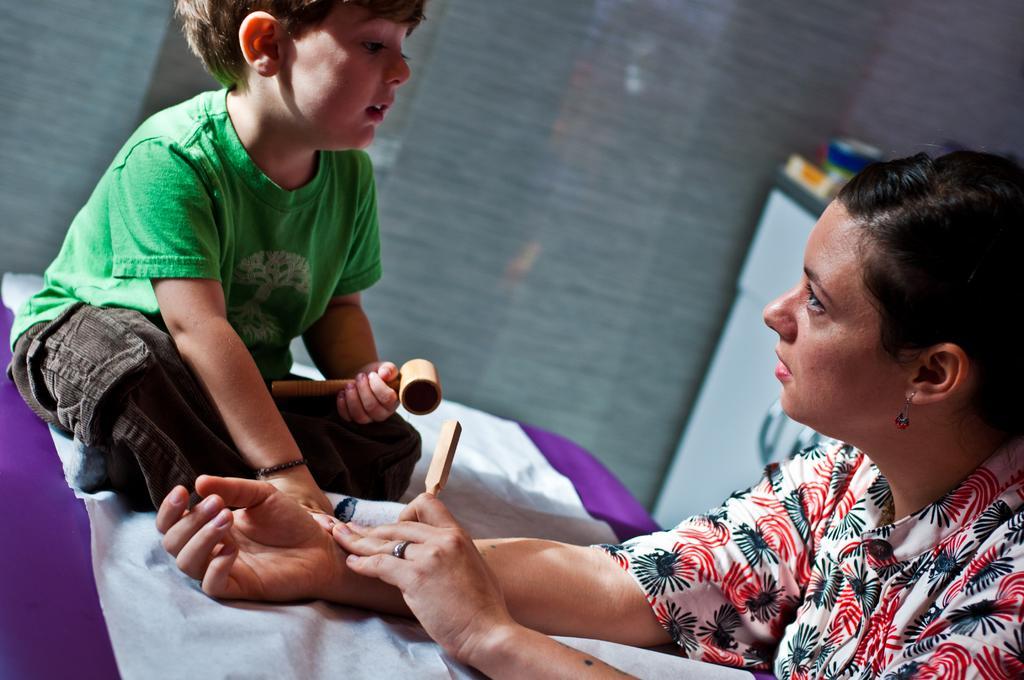In one or two sentences, can you explain what this image depicts? In this image there is a boy wearing a green shirt is sitting on the table having a cloth on it. He is holding a hammer in his hand. Right side there is a woman holding a stick in her hand. She is keeping her hands on the table. Beside her there is a table having few objects on it. Background there is a wall. 